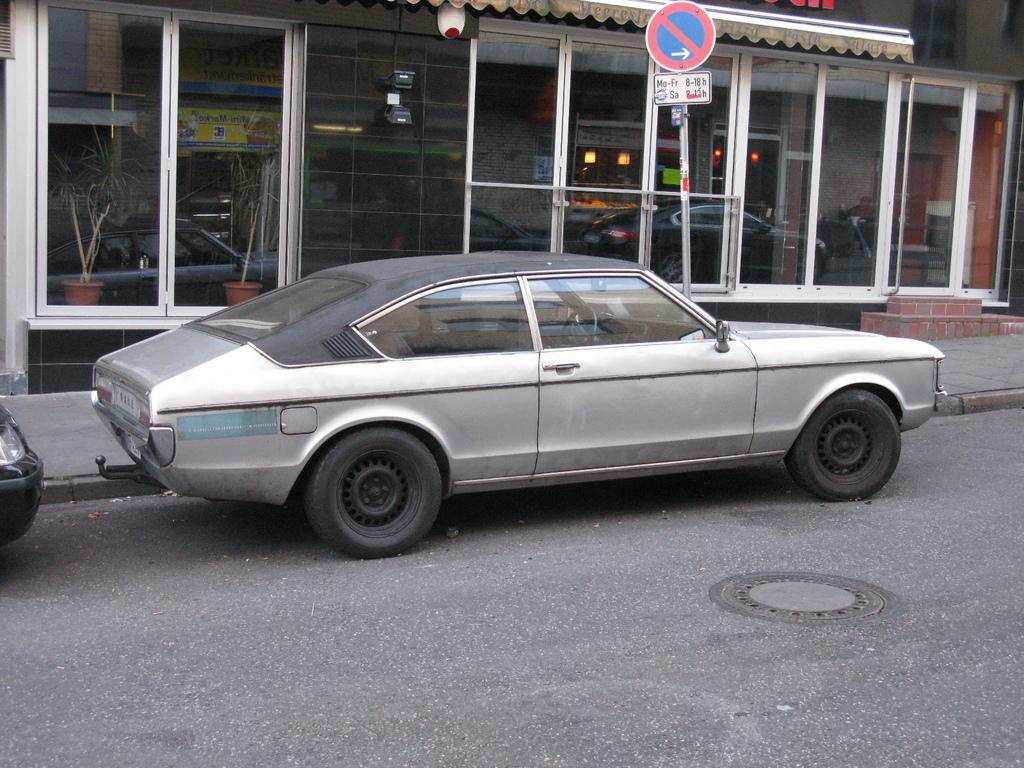Can you describe this image briefly? In the image there is a car parked in front of a showroom and beside the car there is a footpath and on the footpath there is a caution board. 